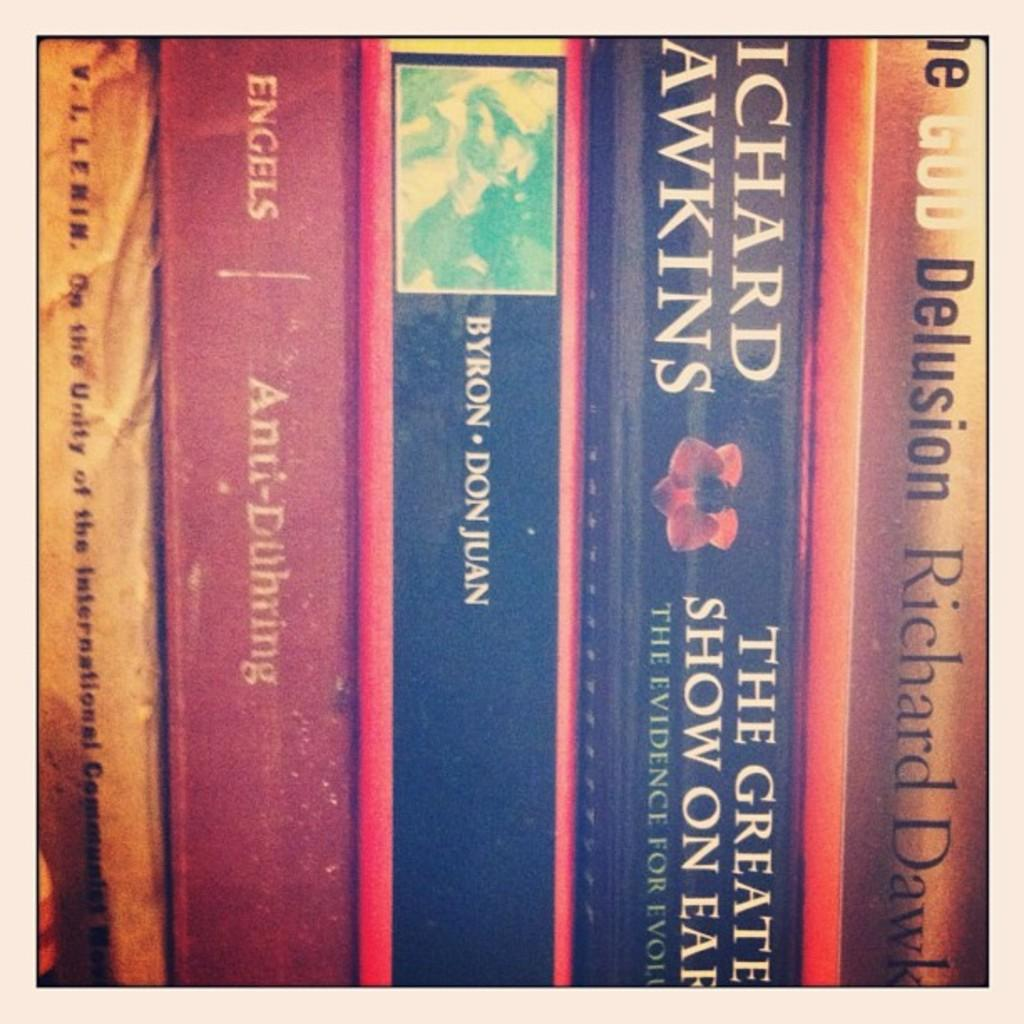<image>
Offer a succinct explanation of the picture presented. Books on a shelf with the one by Byron Don Juan in the middle. 